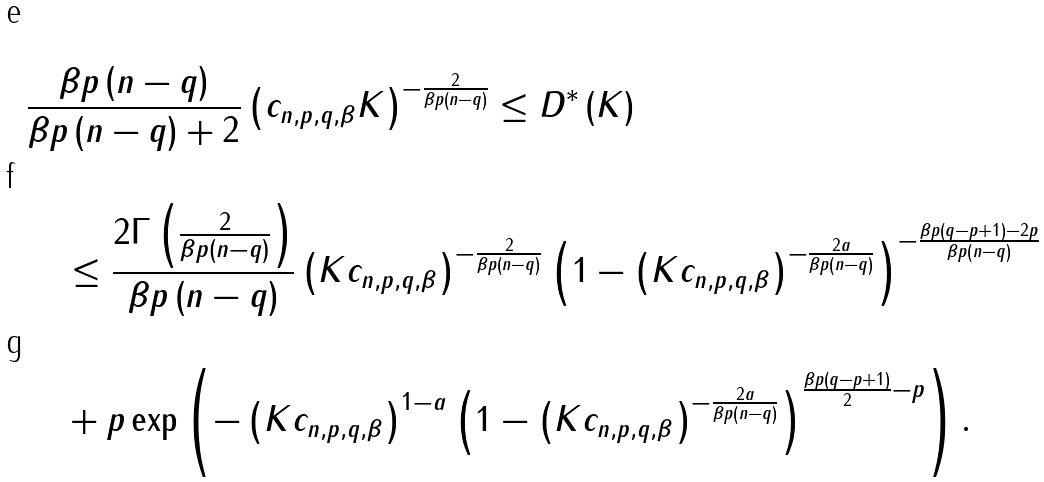Convert formula to latex. <formula><loc_0><loc_0><loc_500><loc_500>& \frac { \beta p \left ( n - q \right ) } { \beta p \left ( n - q \right ) + 2 } \left ( c _ { n , p , q , \beta } K \right ) ^ { - \frac { 2 } { \beta p \left ( n - q \right ) } } \leq D ^ { * } \left ( K \right ) \\ & \quad \leq \frac { 2 \Gamma \left ( \frac { 2 } { \beta p \left ( n - q \right ) } \right ) } { \beta p \left ( n - q \right ) } \left ( K c _ { n , p , q , \beta } \right ) ^ { - \frac { 2 } { \beta p \left ( n - q \right ) } } \left ( 1 - \left ( K c _ { n , p , q , \beta } \right ) ^ { - \frac { 2 a } { \beta p \left ( n - q \right ) } } \right ) ^ { - \frac { \beta p \left ( q - p + 1 \right ) - 2 p } { \beta p \left ( n - q \right ) } } \\ & \quad + p \exp \left ( - \left ( K c _ { n , p , q , \beta } \right ) ^ { 1 - a } \left ( 1 - \left ( K c _ { n , p , q , \beta } \right ) ^ { - \frac { 2 a } { \beta p \left ( n - q \right ) } } \right ) ^ { \frac { \beta p \left ( q - p + 1 \right ) } { 2 } - p } \right ) .</formula> 